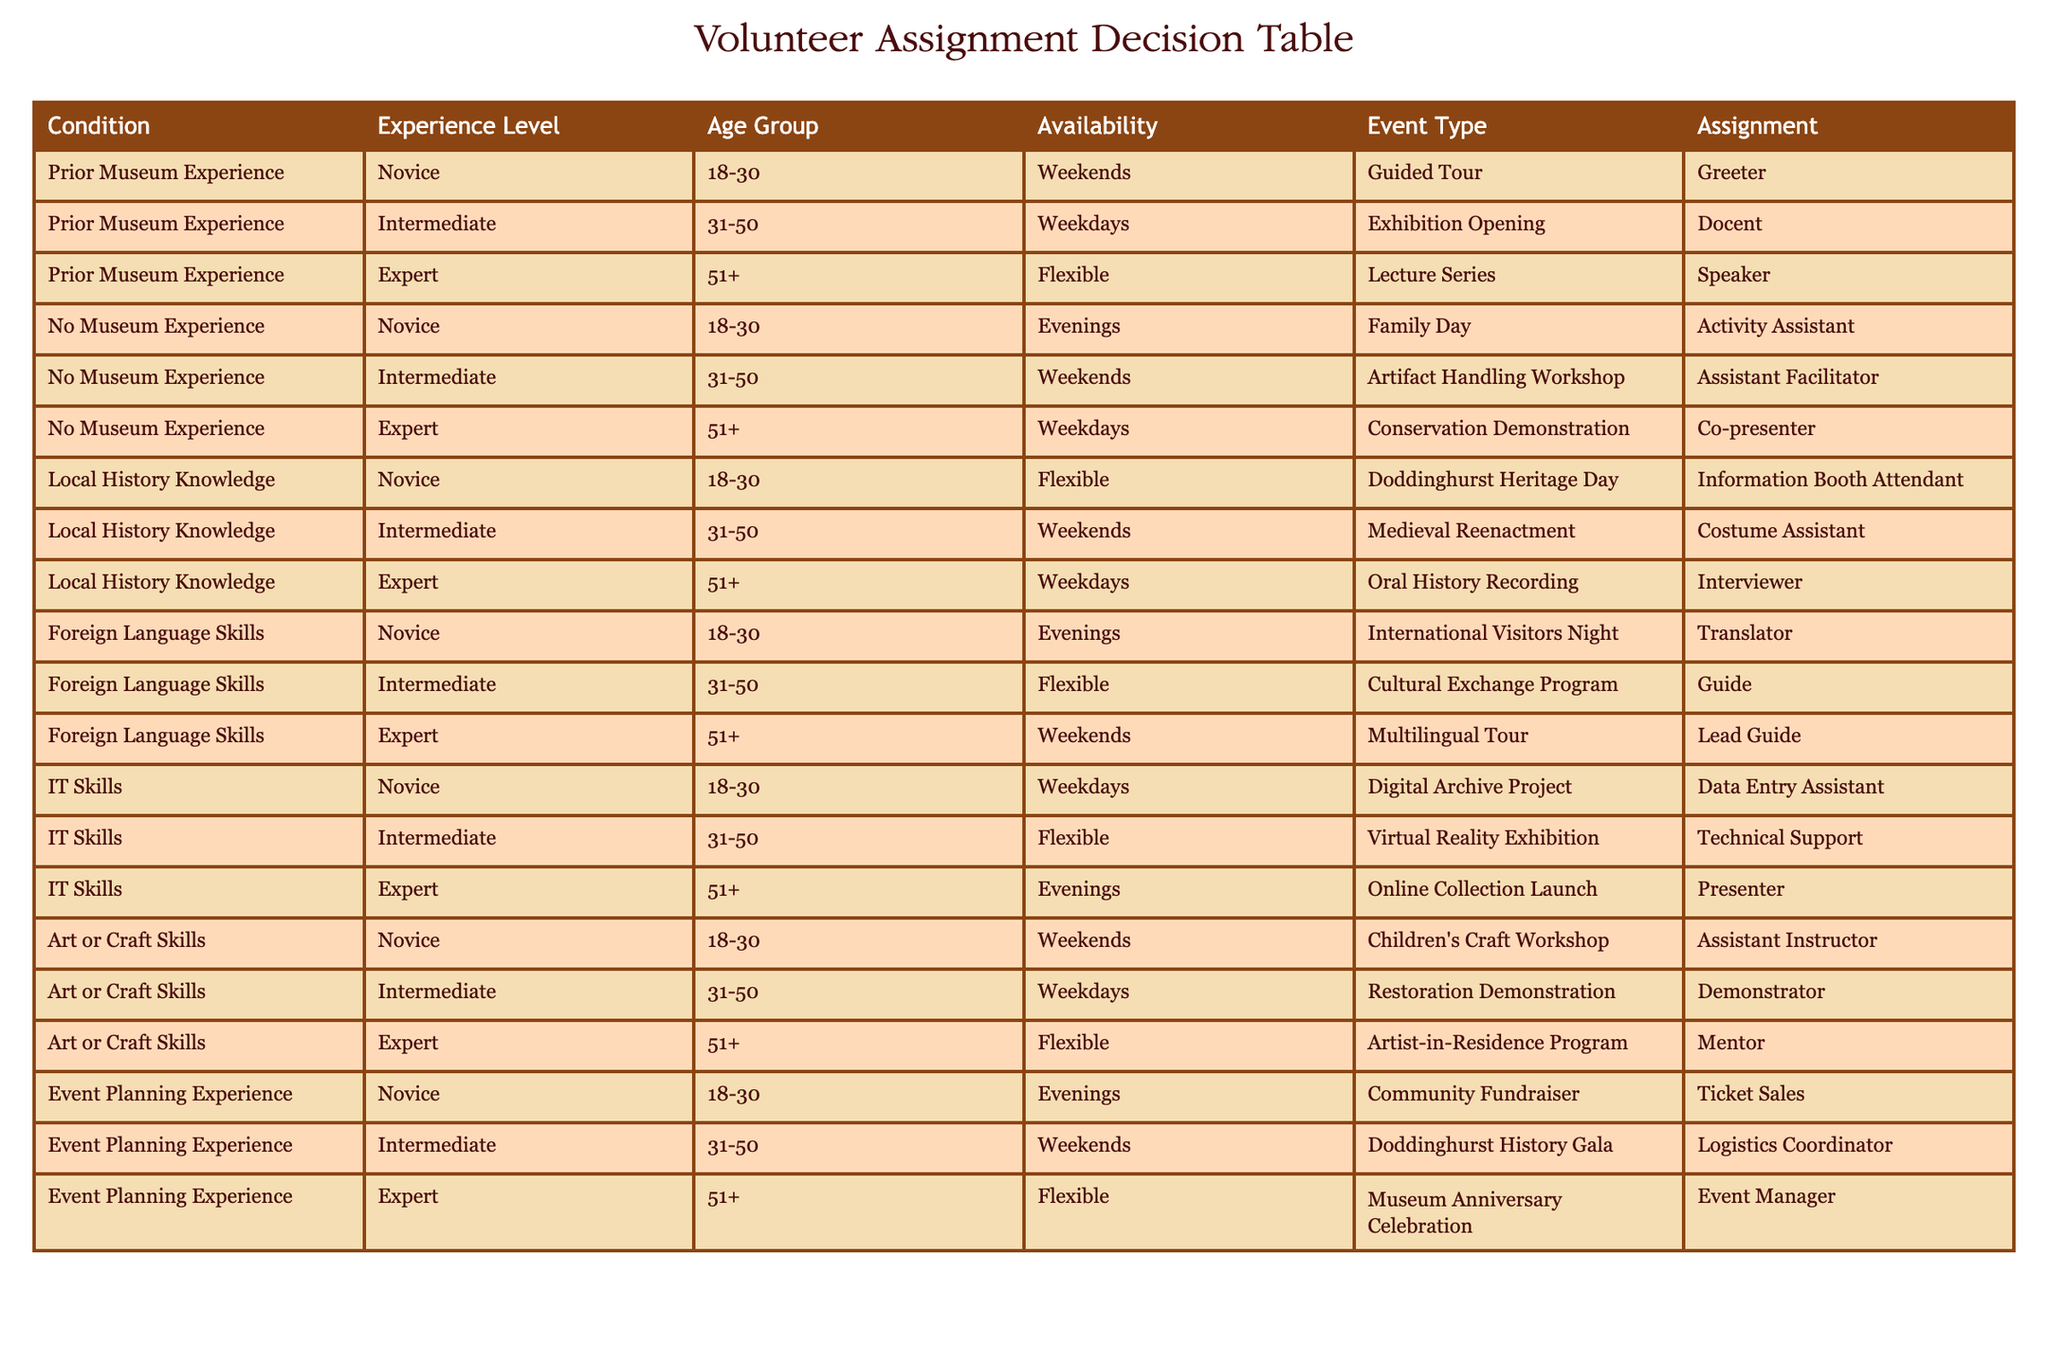What is the assignment for a novice with foreign language skills available on weekends? Looking at the table, we find the row that specifies "Novice," "Foreign Language Skills," and "Weekends." The corresponding assignment in this case is "Lead Guide."
Answer: Lead Guide Which age group is assigned the role of "Docent"? The "Docent" assignment corresponds to the row where the experience level is "Intermediate," the age group is "31-50," and the event type is "Exhibition Opening." Thus, the age group for this assignment is "31-50."
Answer: 31-50 Is there any assignment listed for novices with "Local History Knowledge"? Checking the table, we can find the row for novices with "Local History Knowledge." The assignment noted for them is "Information Booth Attendant," confirming that there is indeed an assignment.
Answer: Yes How many different assignments are available for experts under "IT Skills"? The table lists three assignments under the "IT Skills" category for experts: "Presenter," "Technical Support," and "Data Entry Assistant." Therefore, the total number of assignments is three.
Answer: 3 What event types can a novice with prior museum experience participate in? For novices with prior museum experience, we refer to the relevant section of the table. The "Event Type" entries include "Guided Tour" (Greeter), indicating that there’s only one applicable event type for novices in this category.
Answer: Guided Tour What is the assignment for an expert with art or craft skills who is available flexibly? Evaluating the table, we see that the assignment for an expert with "Art or Craft Skills" who is available flexibly is "Mentor." This is derived from the relevant row that describes this scenario.
Answer: Mentor Can a novice with no museum experience be assigned as a speaker? Upon inspecting the table, we see that "Speaker" is assigned only to experts with prior museum experience. Thus, a novice with no museum experience cannot be assigned to this role.
Answer: No What is the average age group for assignments that require expert level skills? To find the average age group for expert level assignments, we note that the age groups associated with expert assignments are 51+, which means that the average remains the same, as all are drawn from this single age group cohort.
Answer: 51+ 